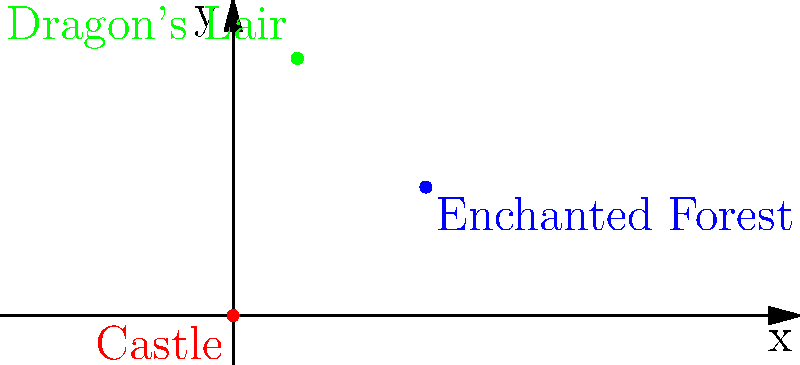In a fairy tale kingdom, you're tasked with creating a coordinate grid to map out important locations. The royal castle is at the origin (0,0), the enchanted forest is at (3,2), and the dragon's lair is at (1,4). If the princess needs to travel from the castle to the dragon's lair to rescue the prince, what is the total distance she must travel in coordinate units? To find the distance between two points on a coordinate plane, we can use the distance formula:

$$ d = \sqrt{(x_2-x_1)^2 + (y_2-y_1)^2} $$

Where $(x_1,y_1)$ is the starting point and $(x_2,y_2)$ is the ending point.

1. The castle (starting point) is at (0,0), so $x_1 = 0$ and $y_1 = 0$.
2. The dragon's lair (ending point) is at (1,4), so $x_2 = 1$ and $y_2 = 4$.

Let's plug these values into the formula:

$$ d = \sqrt{(1-0)^2 + (4-0)^2} $$
$$ d = \sqrt{1^2 + 4^2} $$
$$ d = \sqrt{1 + 16} $$
$$ d = \sqrt{17} $$

Therefore, the princess must travel $\sqrt{17}$ coordinate units to reach the dragon's lair.
Answer: $\sqrt{17}$ units 